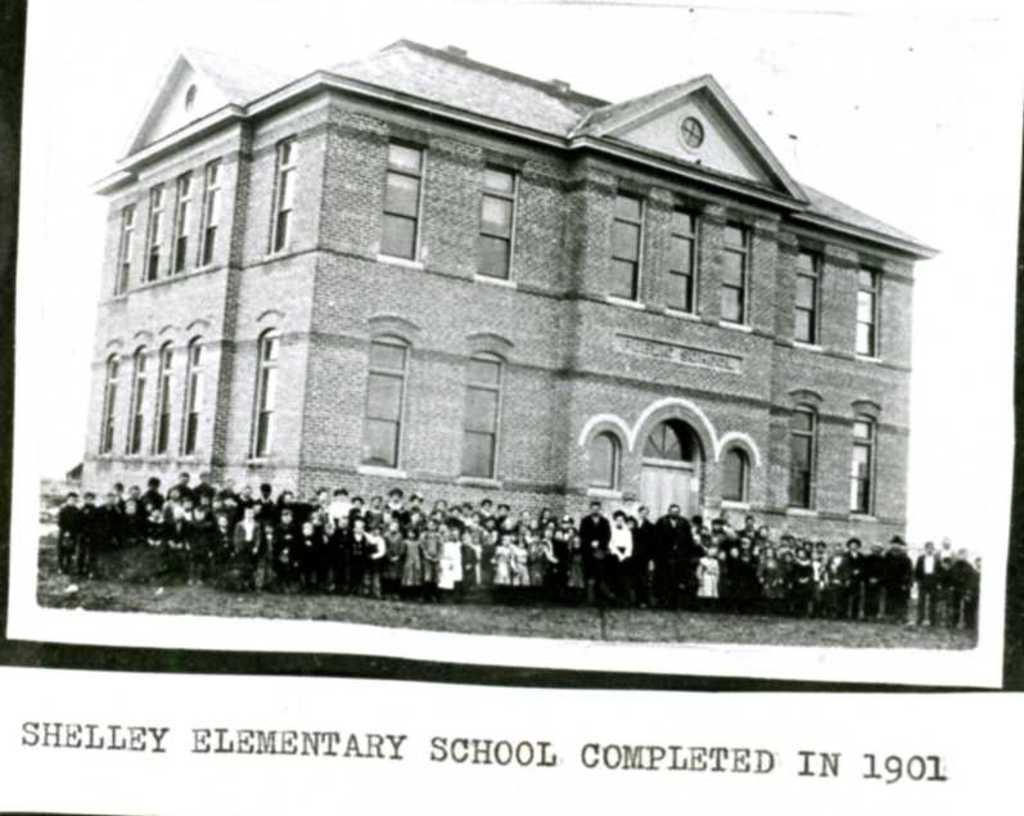What is the main subject of the image? The main subject of the image is a black and white photo of a building. Are there any people in the image? Yes, there are people standing in front of the building. Is there any text visible in the image? Yes, there is some text visible in the image. What type of popcorn is being served in the image? There is no popcorn present in the image. What is the pot used for in the image? There is no pot present in the image. 